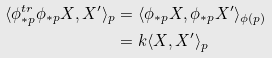<formula> <loc_0><loc_0><loc_500><loc_500>\langle \phi _ { * p } ^ { t r } \phi _ { * p } X , X ^ { \prime } \rangle _ { p } & = \langle \phi _ { * p } X , \phi _ { * p } X ^ { \prime } \rangle _ { \phi ( p ) } \\ & = k \langle X , X ^ { \prime } \rangle _ { p }</formula> 